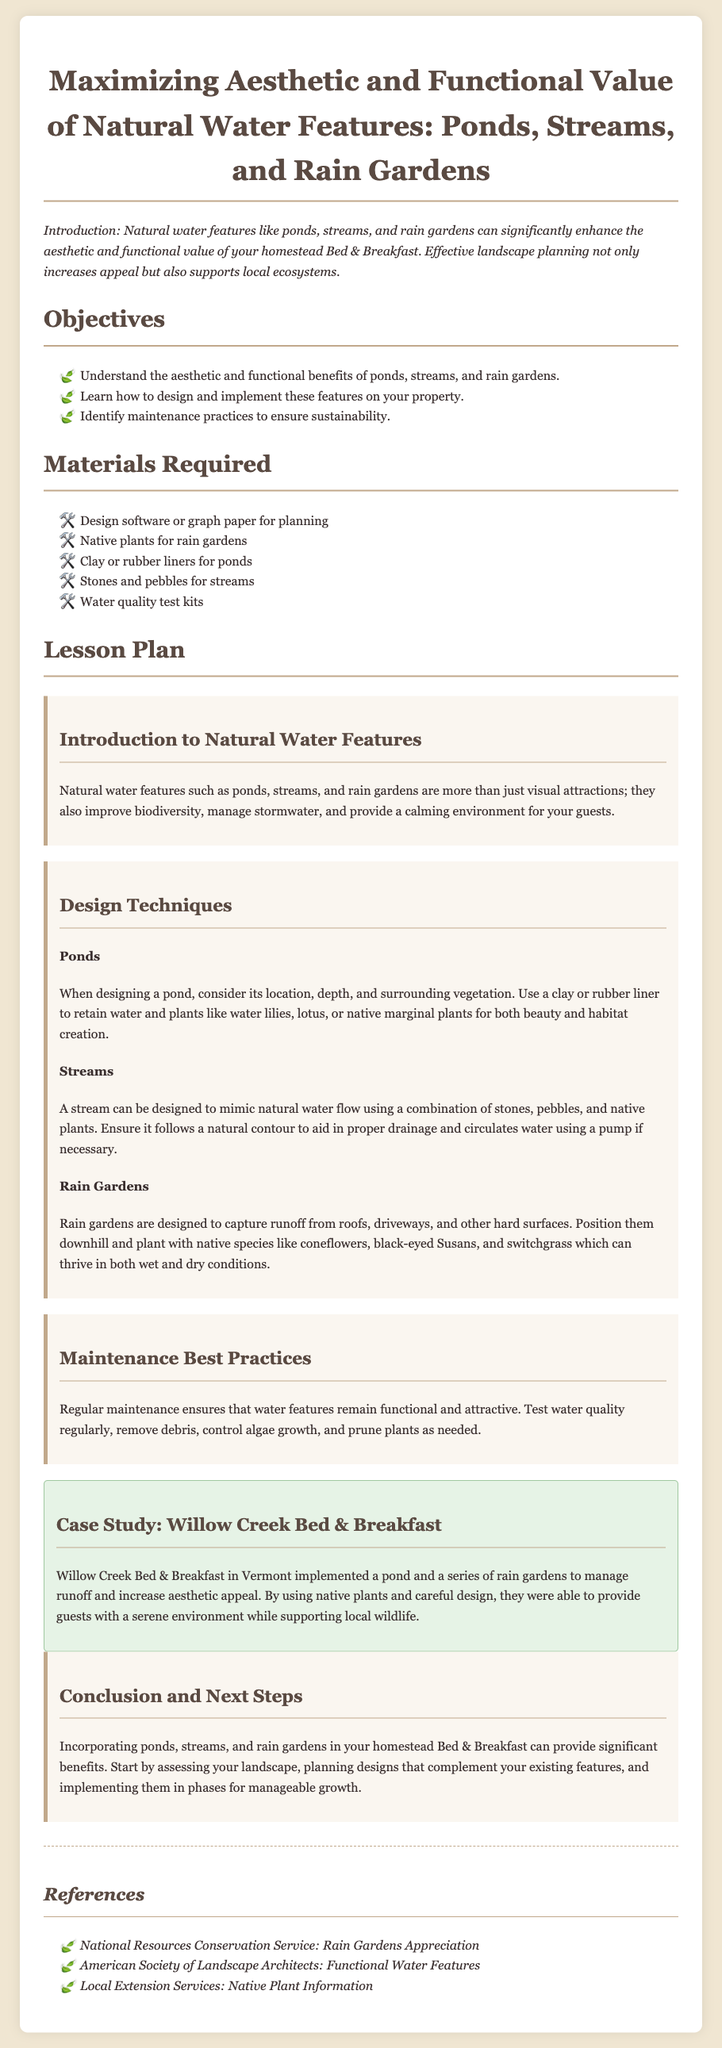what are the objectives of the lesson? The objectives are listed under the "Objectives" section, including understanding benefits, learning design, and identifying maintenance practices.
Answer: Understand the aesthetic and functional benefits of ponds, streams, and rain gardens; Learn how to design and implement these features on your property; Identify maintenance practices to ensure sustainability what materials are required for the lesson? The materials required are detailed in the "Materials Required" section including design tools, native plants, and water quality kits.
Answer: Design software or graph paper for planning; Native plants for rain gardens; Clay or rubber liners for ponds; Stones and pebbles for streams; Water quality test kits what plants are recommended for rain gardens? The document lists specific plants for rain gardens in the "Rain Gardens" subsection under "Design Techniques".
Answer: Coneflowers, black-eyed Susans, and switchgrass what is essential for effective pond design? Key factors for pond design are mentioned in the "Ponds" subsection, outlining considerations such as location and vegetation.
Answer: Location, depth, and surrounding vegetation how often should water quality be tested? Maintenance practices suggest regular testing for water quality but do not specify frequency; the context implies it should be done consistently.
Answer: Regularly what case study is mentioned in the document? The "Case Study" section provides an example of a specific location that implemented water features.
Answer: Willow Creek Bed & Breakfast what is the conclusion regarding the implementation of water features? The conclusion summarizes the benefits and next steps for incorporating water features, focusing on assessment and design planning.
Answer: Assess your landscape, planning designs that complement your existing features, and implementing them in phases for manageable growth what are the benefits of natural water features? The introduction provides insight into the purposes these features serve beyond aesthetics, including ecological improvement and guest experience.
Answer: Enhance aesthetic and functional value, improve biodiversity, manage stormwater, and provide a calming environment 